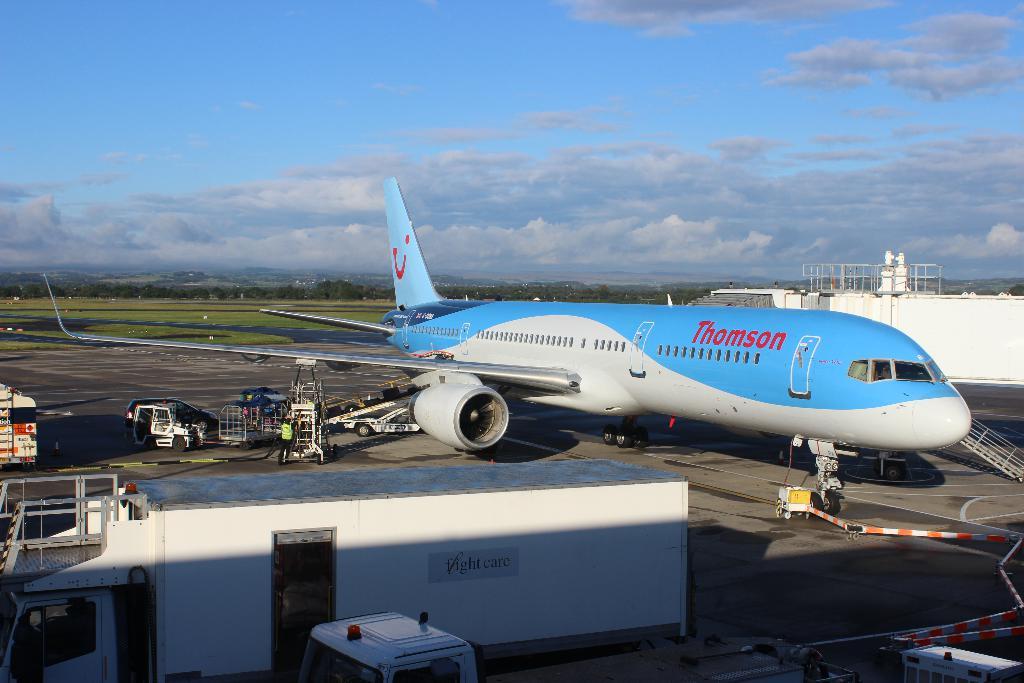Which airline is the flight?
Your answer should be very brief. Thomson. 